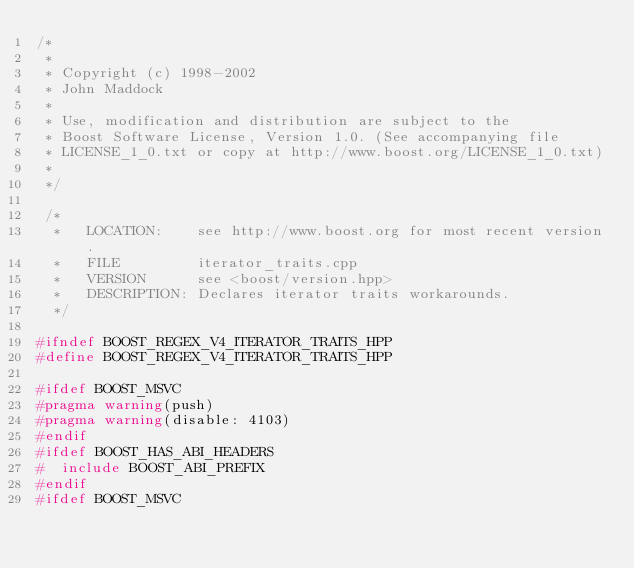Convert code to text. <code><loc_0><loc_0><loc_500><loc_500><_C++_>/*
 *
 * Copyright (c) 1998-2002
 * John Maddock
 *
 * Use, modification and distribution are subject to the 
 * Boost Software License, Version 1.0. (See accompanying file 
 * LICENSE_1_0.txt or copy at http://www.boost.org/LICENSE_1_0.txt)
 *
 */

 /*
  *   LOCATION:    see http://www.boost.org for most recent version.
  *   FILE         iterator_traits.cpp
  *   VERSION      see <boost/version.hpp>
  *   DESCRIPTION: Declares iterator traits workarounds.
  */

#ifndef BOOST_REGEX_V4_ITERATOR_TRAITS_HPP
#define BOOST_REGEX_V4_ITERATOR_TRAITS_HPP

#ifdef BOOST_MSVC
#pragma warning(push)
#pragma warning(disable: 4103)
#endif
#ifdef BOOST_HAS_ABI_HEADERS
#  include BOOST_ABI_PREFIX
#endif
#ifdef BOOST_MSVC</code> 